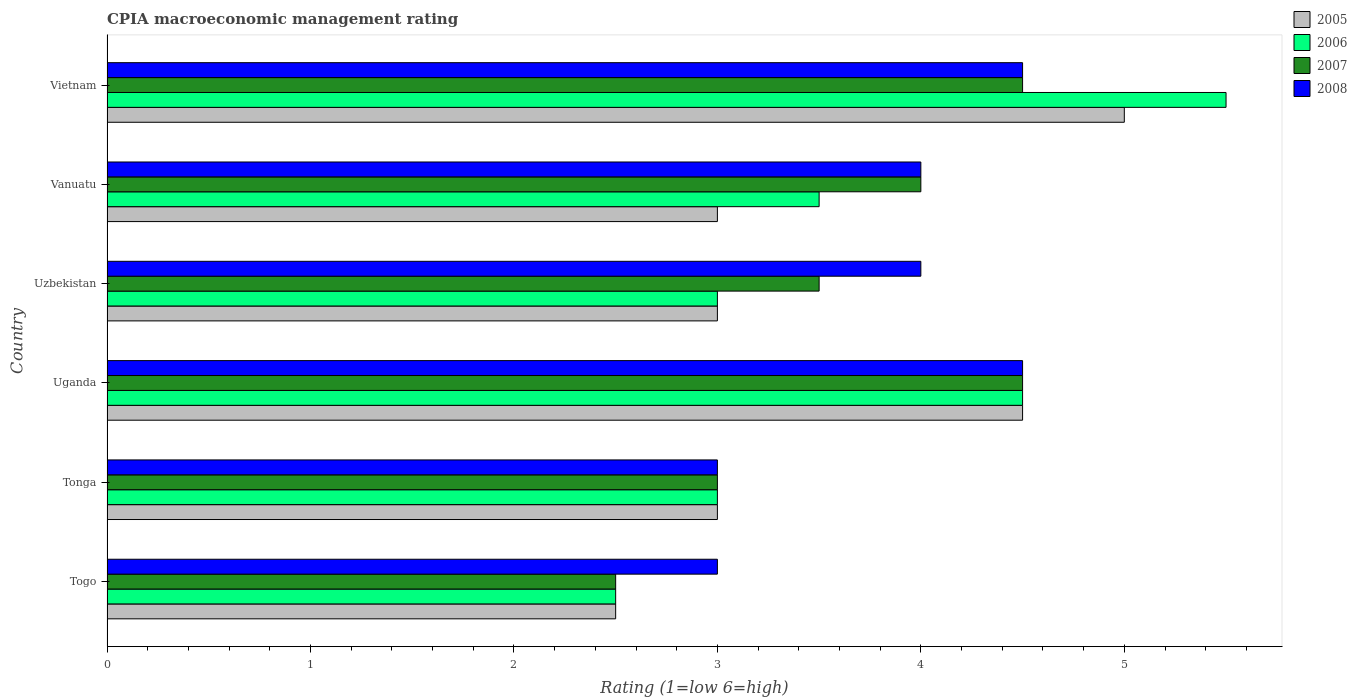How many groups of bars are there?
Keep it short and to the point. 6. Are the number of bars per tick equal to the number of legend labels?
Your answer should be compact. Yes. Are the number of bars on each tick of the Y-axis equal?
Keep it short and to the point. Yes. How many bars are there on the 1st tick from the top?
Provide a succinct answer. 4. How many bars are there on the 6th tick from the bottom?
Give a very brief answer. 4. What is the label of the 5th group of bars from the top?
Offer a very short reply. Tonga. In which country was the CPIA rating in 2007 maximum?
Provide a short and direct response. Uganda. In which country was the CPIA rating in 2005 minimum?
Your response must be concise. Togo. What is the total CPIA rating in 2008 in the graph?
Ensure brevity in your answer.  23. What is the difference between the CPIA rating in 2007 in Uganda and that in Vietnam?
Provide a short and direct response. 0. What is the difference between the CPIA rating in 2006 in Uzbekistan and the CPIA rating in 2007 in Togo?
Ensure brevity in your answer.  0.5. What is the average CPIA rating in 2005 per country?
Keep it short and to the point. 3.5. What is the difference between the CPIA rating in 2005 and CPIA rating in 2006 in Vanuatu?
Give a very brief answer. -0.5. What is the ratio of the CPIA rating in 2006 in Togo to that in Vanuatu?
Ensure brevity in your answer.  0.71. Is the CPIA rating in 2005 in Uzbekistan less than that in Vietnam?
Offer a terse response. Yes. In how many countries, is the CPIA rating in 2005 greater than the average CPIA rating in 2005 taken over all countries?
Your answer should be compact. 2. Is the sum of the CPIA rating in 2006 in Tonga and Vanuatu greater than the maximum CPIA rating in 2005 across all countries?
Provide a succinct answer. Yes. Are all the bars in the graph horizontal?
Give a very brief answer. Yes. How many countries are there in the graph?
Ensure brevity in your answer.  6. What is the difference between two consecutive major ticks on the X-axis?
Give a very brief answer. 1. Does the graph contain any zero values?
Your answer should be compact. No. How many legend labels are there?
Your answer should be compact. 4. How are the legend labels stacked?
Keep it short and to the point. Vertical. What is the title of the graph?
Provide a succinct answer. CPIA macroeconomic management rating. Does "2002" appear as one of the legend labels in the graph?
Give a very brief answer. No. What is the label or title of the X-axis?
Offer a very short reply. Rating (1=low 6=high). What is the Rating (1=low 6=high) in 2005 in Togo?
Keep it short and to the point. 2.5. What is the Rating (1=low 6=high) in 2005 in Tonga?
Ensure brevity in your answer.  3. What is the Rating (1=low 6=high) of 2007 in Tonga?
Give a very brief answer. 3. What is the Rating (1=low 6=high) of 2006 in Uganda?
Your response must be concise. 4.5. What is the Rating (1=low 6=high) of 2007 in Uganda?
Give a very brief answer. 4.5. What is the Rating (1=low 6=high) in 2008 in Uganda?
Your answer should be compact. 4.5. What is the Rating (1=low 6=high) of 2006 in Uzbekistan?
Your answer should be compact. 3. What is the Rating (1=low 6=high) in 2008 in Uzbekistan?
Your answer should be very brief. 4. What is the Rating (1=low 6=high) of 2007 in Vanuatu?
Your answer should be very brief. 4. What is the Rating (1=low 6=high) in 2008 in Vanuatu?
Provide a succinct answer. 4. What is the Rating (1=low 6=high) of 2006 in Vietnam?
Keep it short and to the point. 5.5. Across all countries, what is the maximum Rating (1=low 6=high) in 2005?
Offer a very short reply. 5. Across all countries, what is the maximum Rating (1=low 6=high) of 2006?
Offer a very short reply. 5.5. Across all countries, what is the maximum Rating (1=low 6=high) in 2007?
Provide a succinct answer. 4.5. Across all countries, what is the minimum Rating (1=low 6=high) of 2005?
Your response must be concise. 2.5. Across all countries, what is the minimum Rating (1=low 6=high) in 2007?
Keep it short and to the point. 2.5. Across all countries, what is the minimum Rating (1=low 6=high) in 2008?
Offer a very short reply. 3. What is the total Rating (1=low 6=high) of 2005 in the graph?
Provide a short and direct response. 21. What is the total Rating (1=low 6=high) in 2008 in the graph?
Give a very brief answer. 23. What is the difference between the Rating (1=low 6=high) in 2005 in Togo and that in Tonga?
Your answer should be very brief. -0.5. What is the difference between the Rating (1=low 6=high) of 2006 in Togo and that in Uganda?
Your answer should be very brief. -2. What is the difference between the Rating (1=low 6=high) in 2008 in Togo and that in Uganda?
Your answer should be very brief. -1.5. What is the difference between the Rating (1=low 6=high) of 2006 in Togo and that in Vanuatu?
Provide a short and direct response. -1. What is the difference between the Rating (1=low 6=high) in 2007 in Togo and that in Vanuatu?
Your answer should be very brief. -1.5. What is the difference between the Rating (1=low 6=high) in 2006 in Togo and that in Vietnam?
Your answer should be very brief. -3. What is the difference between the Rating (1=low 6=high) of 2007 in Togo and that in Vietnam?
Your response must be concise. -2. What is the difference between the Rating (1=low 6=high) in 2008 in Togo and that in Vietnam?
Offer a terse response. -1.5. What is the difference between the Rating (1=low 6=high) in 2005 in Tonga and that in Uganda?
Ensure brevity in your answer.  -1.5. What is the difference between the Rating (1=low 6=high) of 2006 in Tonga and that in Uzbekistan?
Make the answer very short. 0. What is the difference between the Rating (1=low 6=high) in 2007 in Tonga and that in Uzbekistan?
Keep it short and to the point. -0.5. What is the difference between the Rating (1=low 6=high) of 2007 in Tonga and that in Vanuatu?
Your answer should be very brief. -1. What is the difference between the Rating (1=low 6=high) of 2005 in Tonga and that in Vietnam?
Make the answer very short. -2. What is the difference between the Rating (1=low 6=high) of 2006 in Tonga and that in Vietnam?
Make the answer very short. -2.5. What is the difference between the Rating (1=low 6=high) in 2007 in Tonga and that in Vietnam?
Keep it short and to the point. -1.5. What is the difference between the Rating (1=low 6=high) in 2008 in Tonga and that in Vietnam?
Ensure brevity in your answer.  -1.5. What is the difference between the Rating (1=low 6=high) in 2006 in Uganda and that in Uzbekistan?
Keep it short and to the point. 1.5. What is the difference between the Rating (1=low 6=high) of 2007 in Uganda and that in Uzbekistan?
Offer a very short reply. 1. What is the difference between the Rating (1=low 6=high) of 2008 in Uganda and that in Uzbekistan?
Make the answer very short. 0.5. What is the difference between the Rating (1=low 6=high) of 2006 in Uganda and that in Vietnam?
Your answer should be compact. -1. What is the difference between the Rating (1=low 6=high) of 2008 in Uganda and that in Vietnam?
Offer a very short reply. 0. What is the difference between the Rating (1=low 6=high) of 2005 in Uzbekistan and that in Vanuatu?
Your answer should be very brief. 0. What is the difference between the Rating (1=low 6=high) of 2006 in Uzbekistan and that in Vanuatu?
Offer a terse response. -0.5. What is the difference between the Rating (1=low 6=high) of 2007 in Uzbekistan and that in Vanuatu?
Provide a succinct answer. -0.5. What is the difference between the Rating (1=low 6=high) in 2008 in Uzbekistan and that in Vanuatu?
Offer a terse response. 0. What is the difference between the Rating (1=low 6=high) in 2005 in Uzbekistan and that in Vietnam?
Your answer should be compact. -2. What is the difference between the Rating (1=low 6=high) in 2007 in Vanuatu and that in Vietnam?
Offer a very short reply. -0.5. What is the difference between the Rating (1=low 6=high) in 2008 in Vanuatu and that in Vietnam?
Offer a terse response. -0.5. What is the difference between the Rating (1=low 6=high) in 2005 in Togo and the Rating (1=low 6=high) in 2006 in Tonga?
Offer a very short reply. -0.5. What is the difference between the Rating (1=low 6=high) in 2005 in Togo and the Rating (1=low 6=high) in 2007 in Tonga?
Your answer should be compact. -0.5. What is the difference between the Rating (1=low 6=high) of 2005 in Togo and the Rating (1=low 6=high) of 2008 in Tonga?
Your answer should be compact. -0.5. What is the difference between the Rating (1=low 6=high) in 2006 in Togo and the Rating (1=low 6=high) in 2008 in Tonga?
Ensure brevity in your answer.  -0.5. What is the difference between the Rating (1=low 6=high) of 2007 in Togo and the Rating (1=low 6=high) of 2008 in Tonga?
Provide a succinct answer. -0.5. What is the difference between the Rating (1=low 6=high) in 2007 in Togo and the Rating (1=low 6=high) in 2008 in Uzbekistan?
Give a very brief answer. -1.5. What is the difference between the Rating (1=low 6=high) of 2005 in Togo and the Rating (1=low 6=high) of 2006 in Vanuatu?
Your answer should be very brief. -1. What is the difference between the Rating (1=low 6=high) of 2006 in Togo and the Rating (1=low 6=high) of 2007 in Vanuatu?
Offer a terse response. -1.5. What is the difference between the Rating (1=low 6=high) in 2007 in Togo and the Rating (1=low 6=high) in 2008 in Vanuatu?
Make the answer very short. -1.5. What is the difference between the Rating (1=low 6=high) of 2005 in Togo and the Rating (1=low 6=high) of 2006 in Vietnam?
Your answer should be very brief. -3. What is the difference between the Rating (1=low 6=high) in 2006 in Togo and the Rating (1=low 6=high) in 2007 in Vietnam?
Your answer should be compact. -2. What is the difference between the Rating (1=low 6=high) in 2007 in Tonga and the Rating (1=low 6=high) in 2008 in Uganda?
Keep it short and to the point. -1.5. What is the difference between the Rating (1=low 6=high) in 2005 in Tonga and the Rating (1=low 6=high) in 2007 in Uzbekistan?
Provide a succinct answer. -0.5. What is the difference between the Rating (1=low 6=high) of 2005 in Tonga and the Rating (1=low 6=high) of 2008 in Uzbekistan?
Ensure brevity in your answer.  -1. What is the difference between the Rating (1=low 6=high) of 2006 in Tonga and the Rating (1=low 6=high) of 2007 in Uzbekistan?
Make the answer very short. -0.5. What is the difference between the Rating (1=low 6=high) of 2007 in Tonga and the Rating (1=low 6=high) of 2008 in Uzbekistan?
Your response must be concise. -1. What is the difference between the Rating (1=low 6=high) of 2005 in Tonga and the Rating (1=low 6=high) of 2006 in Vanuatu?
Your answer should be compact. -0.5. What is the difference between the Rating (1=low 6=high) of 2006 in Tonga and the Rating (1=low 6=high) of 2007 in Vanuatu?
Offer a terse response. -1. What is the difference between the Rating (1=low 6=high) in 2007 in Tonga and the Rating (1=low 6=high) in 2008 in Vanuatu?
Offer a terse response. -1. What is the difference between the Rating (1=low 6=high) of 2005 in Tonga and the Rating (1=low 6=high) of 2006 in Vietnam?
Provide a short and direct response. -2.5. What is the difference between the Rating (1=low 6=high) in 2005 in Tonga and the Rating (1=low 6=high) in 2007 in Vietnam?
Your answer should be compact. -1.5. What is the difference between the Rating (1=low 6=high) of 2006 in Tonga and the Rating (1=low 6=high) of 2008 in Vietnam?
Offer a very short reply. -1.5. What is the difference between the Rating (1=low 6=high) in 2007 in Tonga and the Rating (1=low 6=high) in 2008 in Vietnam?
Provide a succinct answer. -1.5. What is the difference between the Rating (1=low 6=high) in 2005 in Uganda and the Rating (1=low 6=high) in 2006 in Uzbekistan?
Make the answer very short. 1.5. What is the difference between the Rating (1=low 6=high) in 2005 in Uganda and the Rating (1=low 6=high) in 2007 in Uzbekistan?
Provide a succinct answer. 1. What is the difference between the Rating (1=low 6=high) in 2005 in Uganda and the Rating (1=low 6=high) in 2008 in Uzbekistan?
Provide a succinct answer. 0.5. What is the difference between the Rating (1=low 6=high) of 2005 in Uganda and the Rating (1=low 6=high) of 2006 in Vanuatu?
Offer a terse response. 1. What is the difference between the Rating (1=low 6=high) in 2005 in Uganda and the Rating (1=low 6=high) in 2007 in Vanuatu?
Ensure brevity in your answer.  0.5. What is the difference between the Rating (1=low 6=high) in 2006 in Uganda and the Rating (1=low 6=high) in 2007 in Vanuatu?
Provide a succinct answer. 0.5. What is the difference between the Rating (1=low 6=high) of 2005 in Uganda and the Rating (1=low 6=high) of 2006 in Vietnam?
Make the answer very short. -1. What is the difference between the Rating (1=low 6=high) of 2005 in Uganda and the Rating (1=low 6=high) of 2007 in Vietnam?
Offer a very short reply. 0. What is the difference between the Rating (1=low 6=high) of 2005 in Uganda and the Rating (1=low 6=high) of 2008 in Vietnam?
Make the answer very short. 0. What is the difference between the Rating (1=low 6=high) of 2006 in Uganda and the Rating (1=low 6=high) of 2007 in Vietnam?
Your answer should be compact. 0. What is the difference between the Rating (1=low 6=high) of 2006 in Uganda and the Rating (1=low 6=high) of 2008 in Vietnam?
Provide a succinct answer. 0. What is the difference between the Rating (1=low 6=high) of 2007 in Uganda and the Rating (1=low 6=high) of 2008 in Vietnam?
Give a very brief answer. 0. What is the difference between the Rating (1=low 6=high) of 2005 in Uzbekistan and the Rating (1=low 6=high) of 2006 in Vanuatu?
Your response must be concise. -0.5. What is the difference between the Rating (1=low 6=high) of 2006 in Uzbekistan and the Rating (1=low 6=high) of 2008 in Vanuatu?
Offer a terse response. -1. What is the difference between the Rating (1=low 6=high) of 2007 in Uzbekistan and the Rating (1=low 6=high) of 2008 in Vanuatu?
Your answer should be compact. -0.5. What is the difference between the Rating (1=low 6=high) of 2005 in Uzbekistan and the Rating (1=low 6=high) of 2006 in Vietnam?
Your answer should be compact. -2.5. What is the difference between the Rating (1=low 6=high) in 2005 in Uzbekistan and the Rating (1=low 6=high) in 2007 in Vietnam?
Your answer should be compact. -1.5. What is the difference between the Rating (1=low 6=high) of 2005 in Uzbekistan and the Rating (1=low 6=high) of 2008 in Vietnam?
Keep it short and to the point. -1.5. What is the difference between the Rating (1=low 6=high) of 2006 in Uzbekistan and the Rating (1=low 6=high) of 2007 in Vietnam?
Provide a succinct answer. -1.5. What is the difference between the Rating (1=low 6=high) of 2006 in Uzbekistan and the Rating (1=low 6=high) of 2008 in Vietnam?
Your answer should be compact. -1.5. What is the difference between the Rating (1=low 6=high) of 2005 in Vanuatu and the Rating (1=low 6=high) of 2006 in Vietnam?
Make the answer very short. -2.5. What is the difference between the Rating (1=low 6=high) in 2006 in Vanuatu and the Rating (1=low 6=high) in 2008 in Vietnam?
Your response must be concise. -1. What is the average Rating (1=low 6=high) of 2006 per country?
Provide a succinct answer. 3.67. What is the average Rating (1=low 6=high) in 2007 per country?
Offer a very short reply. 3.67. What is the average Rating (1=low 6=high) in 2008 per country?
Keep it short and to the point. 3.83. What is the difference between the Rating (1=low 6=high) of 2005 and Rating (1=low 6=high) of 2008 in Togo?
Keep it short and to the point. -0.5. What is the difference between the Rating (1=low 6=high) in 2007 and Rating (1=low 6=high) in 2008 in Togo?
Provide a short and direct response. -0.5. What is the difference between the Rating (1=low 6=high) in 2005 and Rating (1=low 6=high) in 2006 in Tonga?
Ensure brevity in your answer.  0. What is the difference between the Rating (1=low 6=high) of 2005 and Rating (1=low 6=high) of 2008 in Tonga?
Offer a very short reply. 0. What is the difference between the Rating (1=low 6=high) in 2006 and Rating (1=low 6=high) in 2007 in Tonga?
Provide a succinct answer. 0. What is the difference between the Rating (1=low 6=high) in 2006 and Rating (1=low 6=high) in 2008 in Tonga?
Provide a succinct answer. 0. What is the difference between the Rating (1=low 6=high) in 2007 and Rating (1=low 6=high) in 2008 in Tonga?
Your answer should be compact. 0. What is the difference between the Rating (1=low 6=high) of 2005 and Rating (1=low 6=high) of 2008 in Uganda?
Your response must be concise. 0. What is the difference between the Rating (1=low 6=high) of 2006 and Rating (1=low 6=high) of 2007 in Uganda?
Your answer should be compact. 0. What is the difference between the Rating (1=low 6=high) of 2005 and Rating (1=low 6=high) of 2006 in Uzbekistan?
Keep it short and to the point. 0. What is the difference between the Rating (1=low 6=high) of 2006 and Rating (1=low 6=high) of 2007 in Uzbekistan?
Your answer should be compact. -0.5. What is the difference between the Rating (1=low 6=high) in 2007 and Rating (1=low 6=high) in 2008 in Uzbekistan?
Keep it short and to the point. -0.5. What is the difference between the Rating (1=low 6=high) of 2006 and Rating (1=low 6=high) of 2007 in Vanuatu?
Provide a short and direct response. -0.5. What is the difference between the Rating (1=low 6=high) of 2006 and Rating (1=low 6=high) of 2008 in Vanuatu?
Offer a very short reply. -0.5. What is the difference between the Rating (1=low 6=high) of 2007 and Rating (1=low 6=high) of 2008 in Vanuatu?
Give a very brief answer. 0. What is the difference between the Rating (1=low 6=high) of 2005 and Rating (1=low 6=high) of 2008 in Vietnam?
Your response must be concise. 0.5. What is the difference between the Rating (1=low 6=high) of 2007 and Rating (1=low 6=high) of 2008 in Vietnam?
Provide a succinct answer. 0. What is the ratio of the Rating (1=low 6=high) of 2005 in Togo to that in Uganda?
Ensure brevity in your answer.  0.56. What is the ratio of the Rating (1=low 6=high) in 2006 in Togo to that in Uganda?
Provide a succinct answer. 0.56. What is the ratio of the Rating (1=low 6=high) of 2007 in Togo to that in Uganda?
Your response must be concise. 0.56. What is the ratio of the Rating (1=low 6=high) of 2006 in Togo to that in Uzbekistan?
Your answer should be compact. 0.83. What is the ratio of the Rating (1=low 6=high) of 2008 in Togo to that in Uzbekistan?
Offer a terse response. 0.75. What is the ratio of the Rating (1=low 6=high) of 2008 in Togo to that in Vanuatu?
Your answer should be very brief. 0.75. What is the ratio of the Rating (1=low 6=high) in 2006 in Togo to that in Vietnam?
Your answer should be very brief. 0.45. What is the ratio of the Rating (1=low 6=high) in 2007 in Togo to that in Vietnam?
Your answer should be compact. 0.56. What is the ratio of the Rating (1=low 6=high) of 2008 in Togo to that in Vietnam?
Give a very brief answer. 0.67. What is the ratio of the Rating (1=low 6=high) of 2006 in Tonga to that in Uganda?
Your answer should be very brief. 0.67. What is the ratio of the Rating (1=low 6=high) in 2007 in Tonga to that in Uganda?
Your answer should be compact. 0.67. What is the ratio of the Rating (1=low 6=high) of 2008 in Tonga to that in Uganda?
Make the answer very short. 0.67. What is the ratio of the Rating (1=low 6=high) of 2008 in Tonga to that in Uzbekistan?
Keep it short and to the point. 0.75. What is the ratio of the Rating (1=low 6=high) of 2007 in Tonga to that in Vanuatu?
Give a very brief answer. 0.75. What is the ratio of the Rating (1=low 6=high) of 2008 in Tonga to that in Vanuatu?
Offer a terse response. 0.75. What is the ratio of the Rating (1=low 6=high) in 2005 in Tonga to that in Vietnam?
Provide a succinct answer. 0.6. What is the ratio of the Rating (1=low 6=high) of 2006 in Tonga to that in Vietnam?
Offer a terse response. 0.55. What is the ratio of the Rating (1=low 6=high) in 2006 in Uganda to that in Vietnam?
Provide a short and direct response. 0.82. What is the ratio of the Rating (1=low 6=high) of 2007 in Uzbekistan to that in Vanuatu?
Give a very brief answer. 0.88. What is the ratio of the Rating (1=low 6=high) in 2008 in Uzbekistan to that in Vanuatu?
Provide a succinct answer. 1. What is the ratio of the Rating (1=low 6=high) in 2005 in Uzbekistan to that in Vietnam?
Make the answer very short. 0.6. What is the ratio of the Rating (1=low 6=high) in 2006 in Uzbekistan to that in Vietnam?
Provide a succinct answer. 0.55. What is the ratio of the Rating (1=low 6=high) in 2007 in Uzbekistan to that in Vietnam?
Ensure brevity in your answer.  0.78. What is the ratio of the Rating (1=low 6=high) of 2008 in Uzbekistan to that in Vietnam?
Offer a terse response. 0.89. What is the ratio of the Rating (1=low 6=high) of 2006 in Vanuatu to that in Vietnam?
Offer a terse response. 0.64. What is the ratio of the Rating (1=low 6=high) of 2007 in Vanuatu to that in Vietnam?
Make the answer very short. 0.89. What is the ratio of the Rating (1=low 6=high) in 2008 in Vanuatu to that in Vietnam?
Provide a short and direct response. 0.89. What is the difference between the highest and the second highest Rating (1=low 6=high) in 2005?
Provide a succinct answer. 0.5. What is the difference between the highest and the lowest Rating (1=low 6=high) in 2007?
Provide a short and direct response. 2. What is the difference between the highest and the lowest Rating (1=low 6=high) in 2008?
Your answer should be very brief. 1.5. 